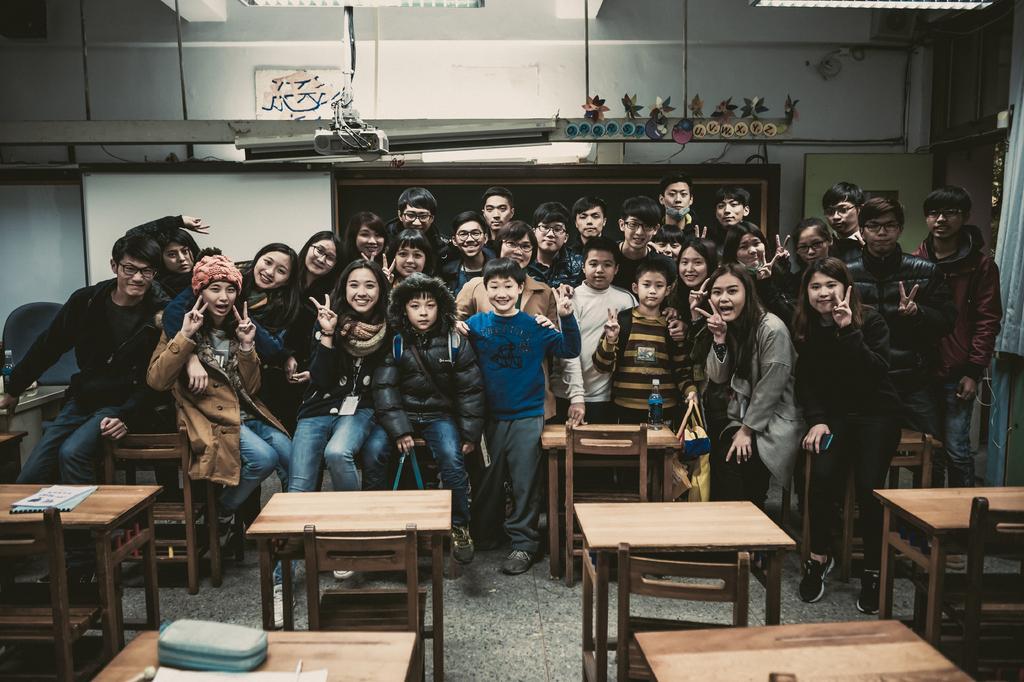Describe this image in one or two sentences. In this picture there are group of people some are sitting and some are standing. There is a bottle on the table. There is a chair. There is a box and other objects on the table. There is a cloth. 